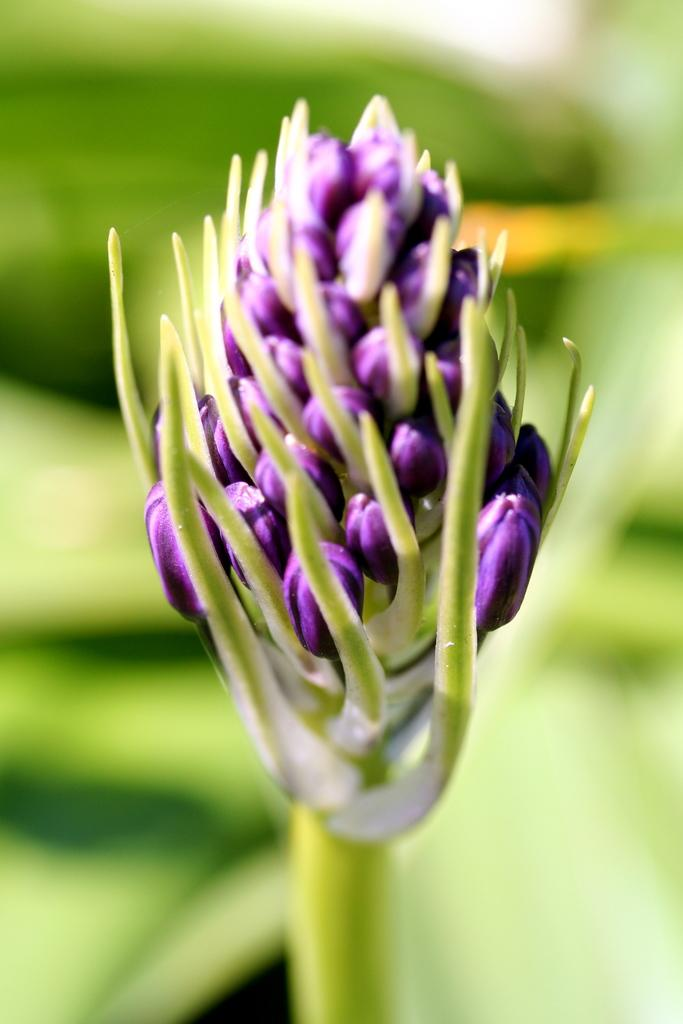What is present in the image that represents a plant's growth? There are buds and a stem in the image. Can you describe the background of the image? The background of the image is blurred. How does the plant in the image demonstrate respect for its environment? The image does not show any indication of the plant's interaction with its environment, nor does it suggest that the plant is capable of demonstrating respect. 